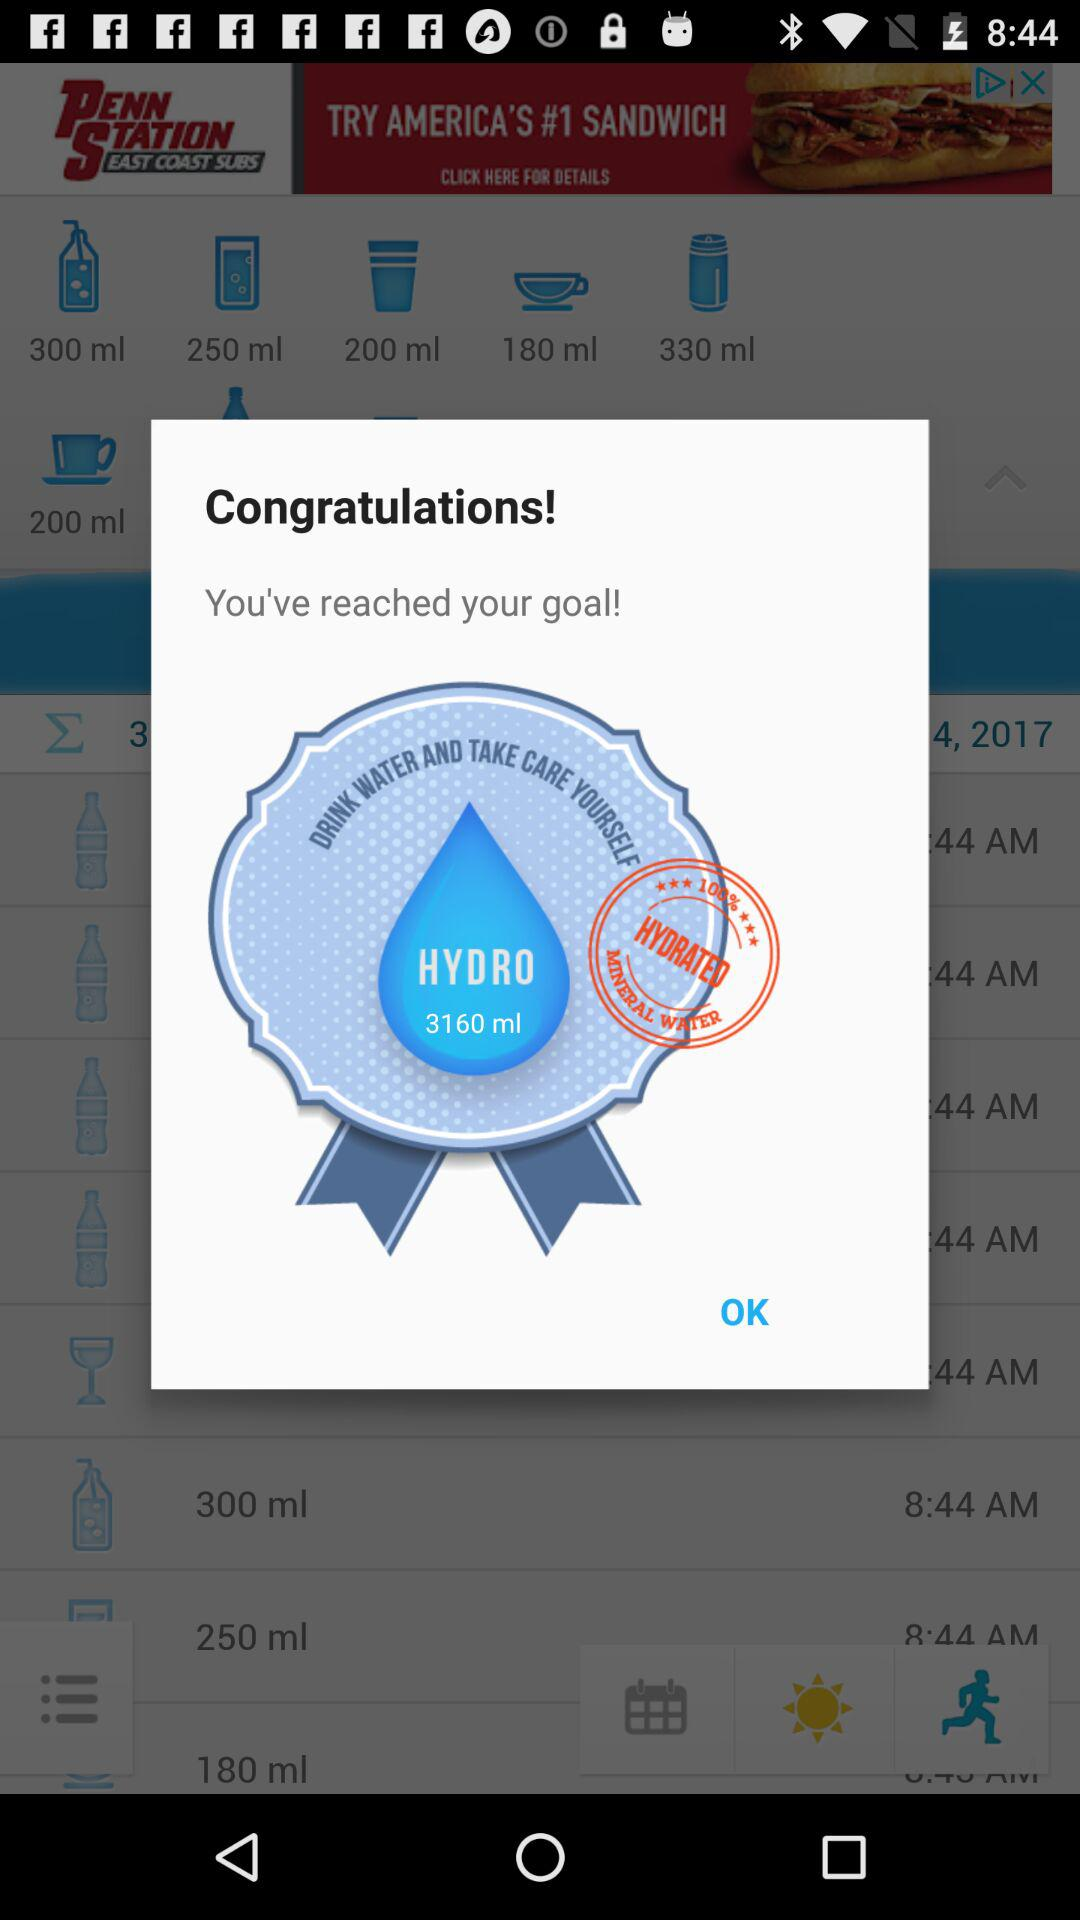What is the goal for Hydro? The goal is 3160 ml. 